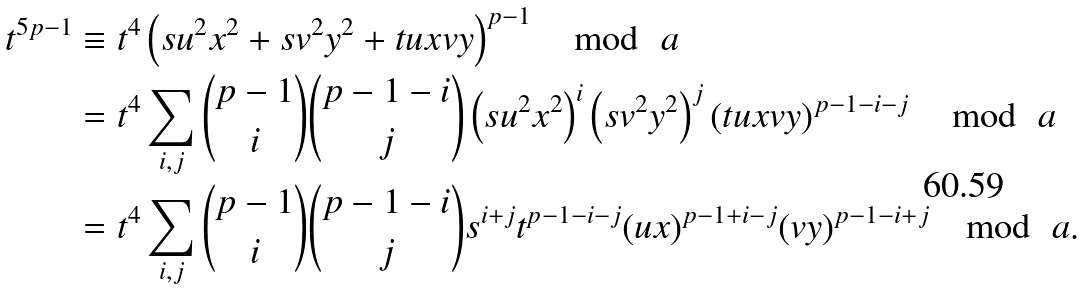Convert formula to latex. <formula><loc_0><loc_0><loc_500><loc_500>t ^ { 5 p - 1 } & \equiv t ^ { 4 } \left ( s u ^ { 2 } x ^ { 2 } + s v ^ { 2 } y ^ { 2 } + t u x v y \right ) ^ { p - 1 } \mod \ a \\ & = t ^ { 4 } \sum _ { i , j } \binom { p - 1 } { i } \binom { p - 1 - i } { j } \left ( s u ^ { 2 } x ^ { 2 } \right ) ^ { i } \left ( s v ^ { 2 } y ^ { 2 } \right ) ^ { j } \left ( t u x v y \right ) ^ { p - 1 - i - j } \mod \ a \\ & = t ^ { 4 } \sum _ { i , j } \binom { p - 1 } { i } \binom { p - 1 - i } { j } s ^ { i + j } t ^ { p - 1 - i - j } ( u x ) ^ { p - 1 + i - j } ( v y ) ^ { p - 1 - i + j } \mod \ a .</formula> 